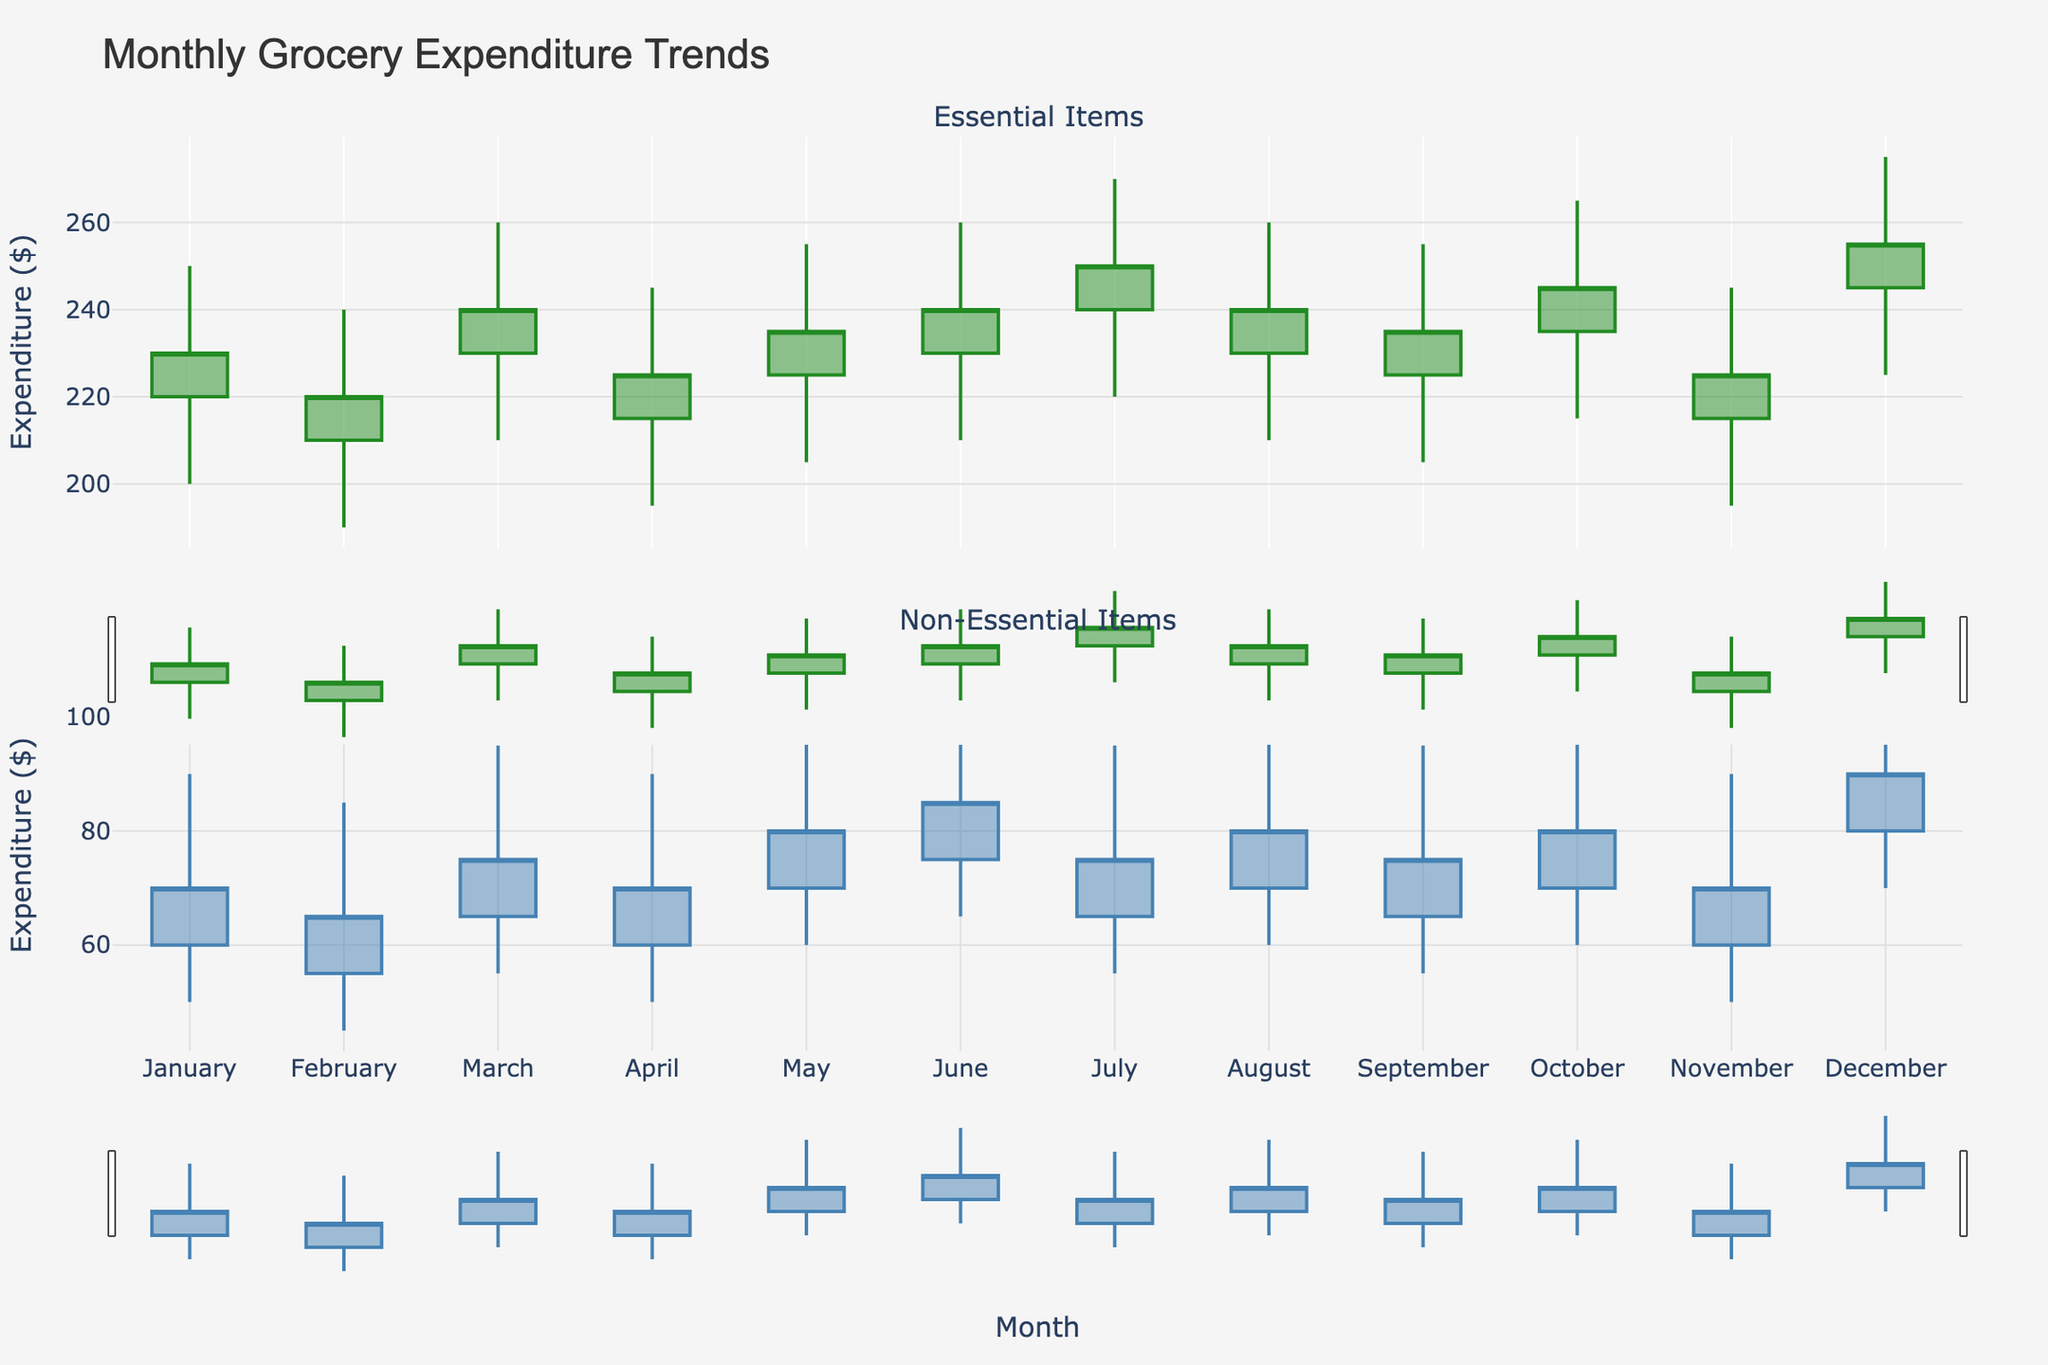How does December's essential item expenditure compare to January's? In December, the close value of essential items is 255, whereas in January, it is 230. Therefore, December's expenditure on essential items is higher compared to January's.
Answer: December's expenditure is higher Which month had the lowest closing expenditure for non-essential items? By checking the closing values for non-essential items across all months, February has the lowest closing expenditure of 65.
Answer: February What is the trend in essential item expenditure over the year? Observing the candlestick plots for essential items, the general trend shows increasing values, especially in the latter months, with December peaking at 255.
Answer: Increasing What months show a significant increase in non-essential item expenditure? A significant increase can be observed where the open value is much lower than the close value. For non-essential items, months like June (75 to 85) and December (80 to 90) show significant increases.
Answer: June and December How does July's essential expenditure closing value compare to June's? The essential item closing value in July is 250, while in June it is 240. Thus, July’s value is higher than June’s by 10.
Answer: Higher by 10 What is the difference between the highest and lowest closing values for essential items throughout the year? The highest closing value for essential items is 255 (December), and the lowest is 225 (April). The difference is 255 - 225 = 30.
Answer: 30 Which month saw the highest increase in non-essential item expenditure based on open and close values? Calculating the differences between open and close for non-essential items, December had an increase from 80 to 90, which is the highest increase of 10.
Answer: December In which month were the essential item high values the highest? Checking the high values for essential items, December has the highest high value of 275.
Answer: December What is the overall trend of non-essential item expenditure from January to December? Looking at the non-essential item plots, there is a general trend of gradual increase from January’s close of 70 to December’s close of 90.
Answer: Gradual Increase 